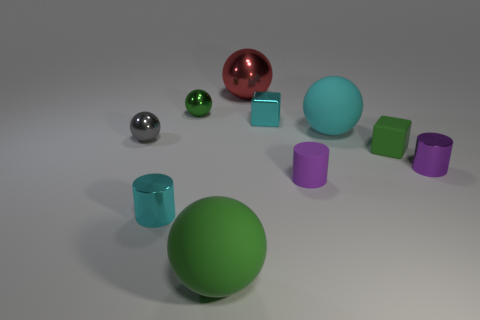What number of objects are red rubber things or cyan things?
Offer a very short reply. 3. Is the number of green rubber balls greater than the number of brown rubber cylinders?
Give a very brief answer. Yes. There is a cyan shiny thing that is behind the big rubber ball behind the gray thing; what is its size?
Offer a very short reply. Small. The other large matte thing that is the same shape as the big green matte object is what color?
Provide a succinct answer. Cyan. What is the size of the rubber block?
Your answer should be very brief. Small. What number of spheres are green things or big green rubber things?
Offer a very short reply. 2. The rubber thing that is the same shape as the tiny purple shiny object is what size?
Keep it short and to the point. Small. How many big brown rubber balls are there?
Keep it short and to the point. 0. Is the shape of the purple shiny thing the same as the cyan shiny thing that is behind the small purple matte object?
Your answer should be very brief. No. What size is the green ball to the left of the large green object?
Your response must be concise. Small. 